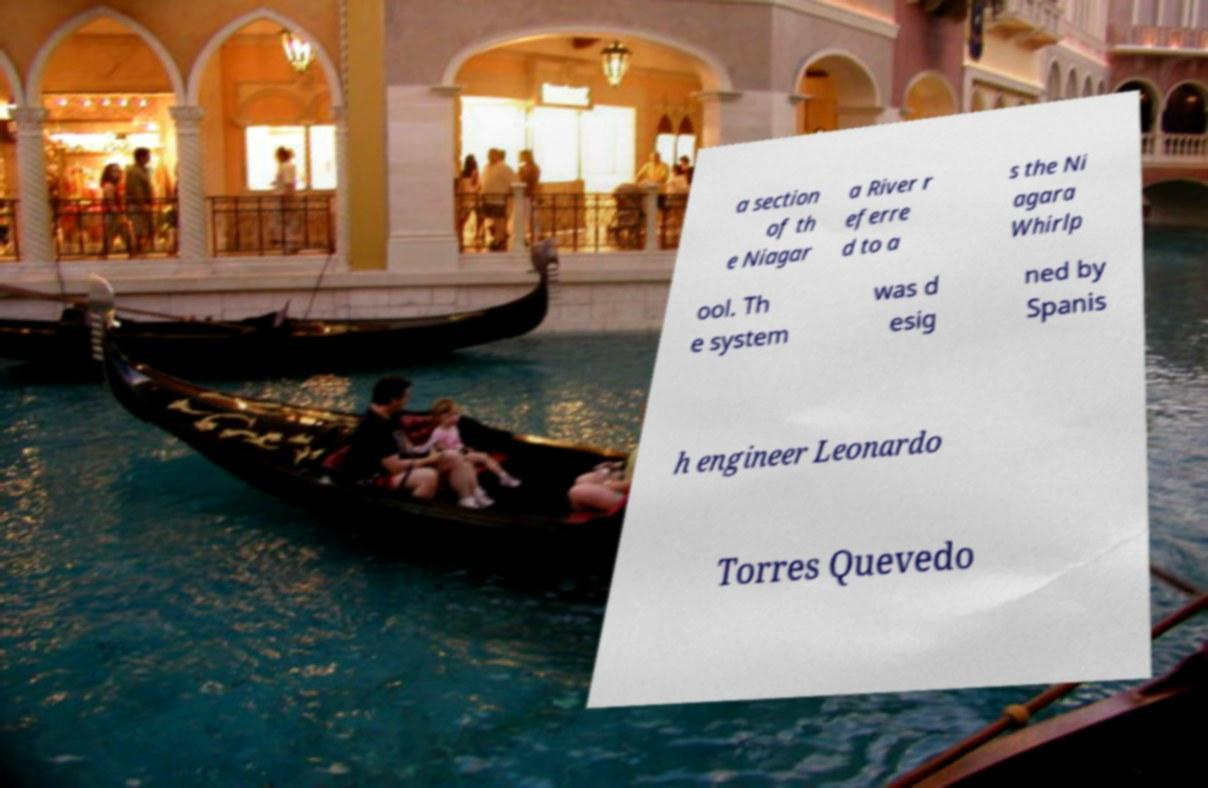Can you read and provide the text displayed in the image?This photo seems to have some interesting text. Can you extract and type it out for me? a section of th e Niagar a River r eferre d to a s the Ni agara Whirlp ool. Th e system was d esig ned by Spanis h engineer Leonardo Torres Quevedo 